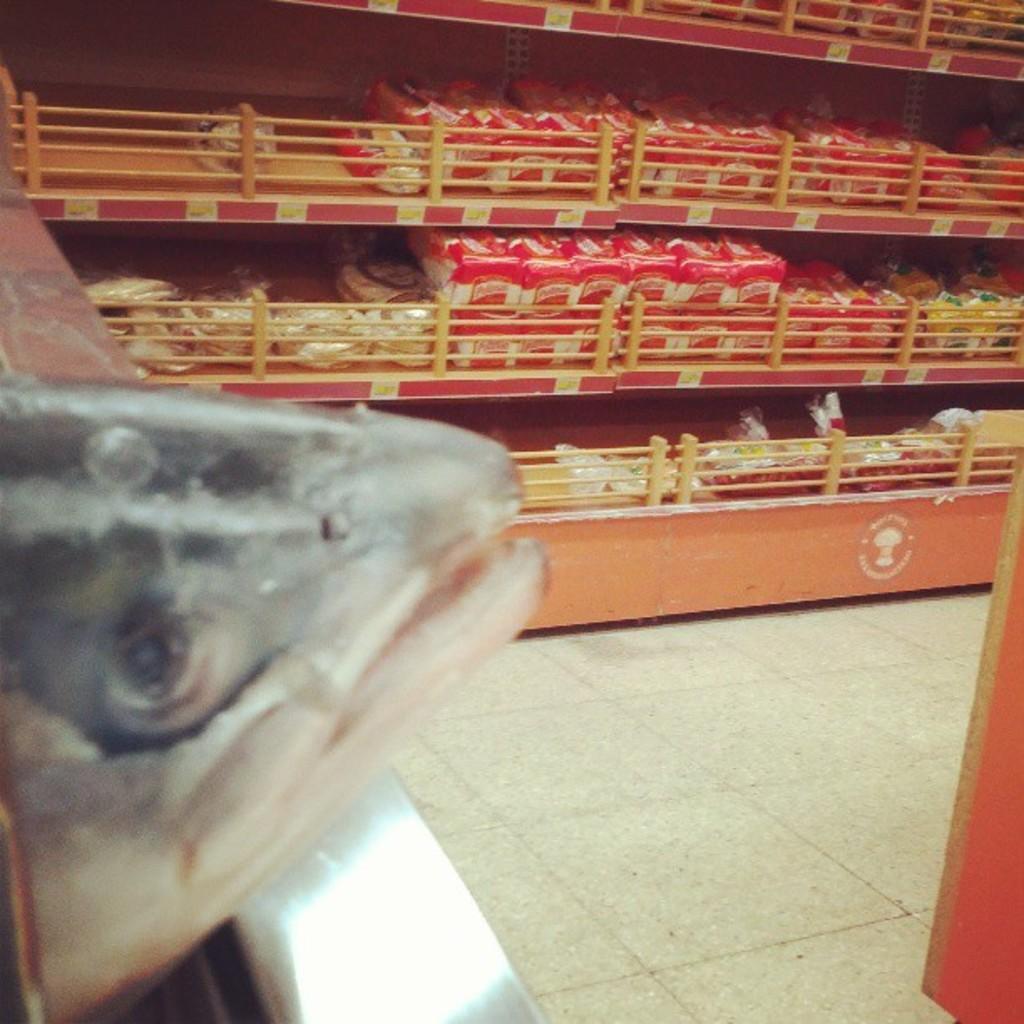Could you give a brief overview of what you see in this image? In the image there is fish on the left side and in the back there are racks with many groceries in it. 